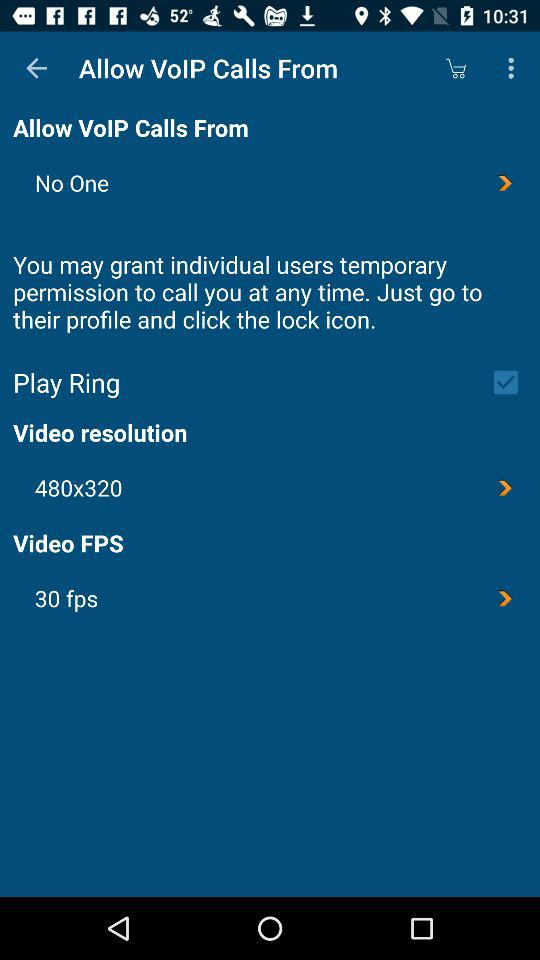What is the video resolution? The video resolution is 480×320. 